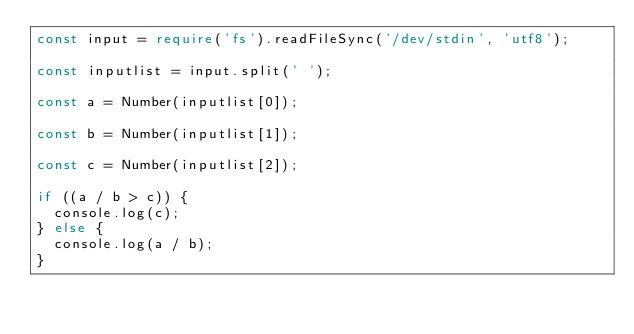<code> <loc_0><loc_0><loc_500><loc_500><_TypeScript_>const input = require('fs').readFileSync('/dev/stdin', 'utf8');

const inputlist = input.split(' ');

const a = Number(inputlist[0]);

const b = Number(inputlist[1]);

const c = Number(inputlist[2]);

if ((a / b > c)) {
  console.log(c);
} else {
  console.log(a / b);
}</code> 